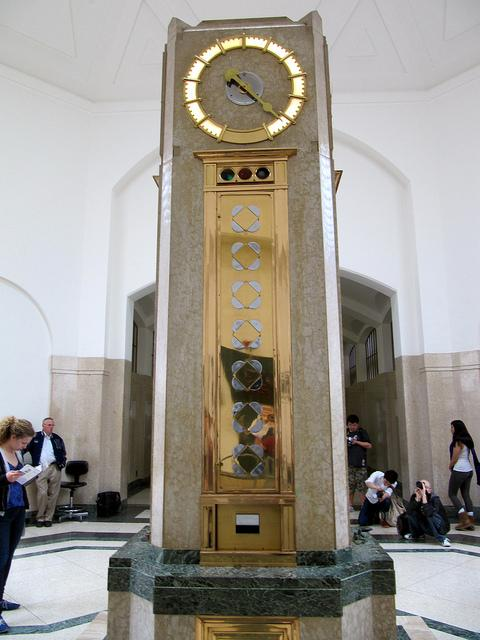The hand of the clock is closest to what number? Please explain your reasoning. five. The hand is at the five. 